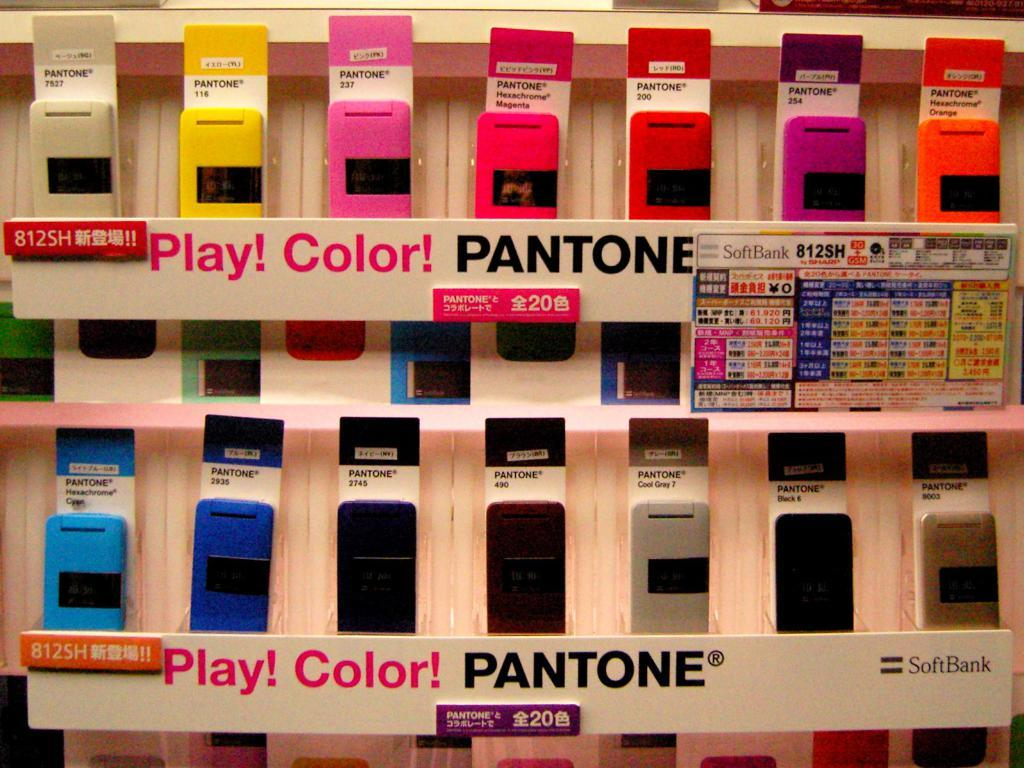<image>
Write a terse but informative summary of the picture. A lot of different colored Pantone phone cases sit on a shelf. 